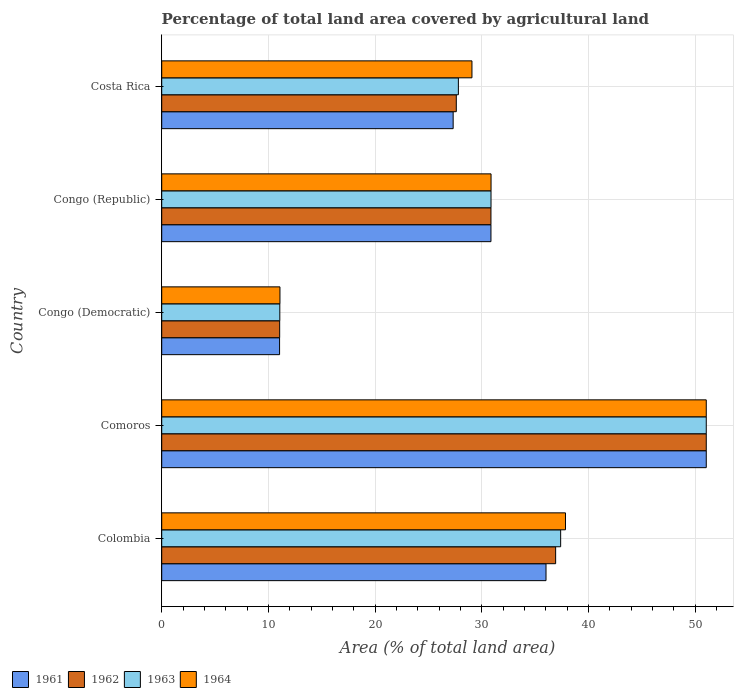How many different coloured bars are there?
Provide a short and direct response. 4. How many groups of bars are there?
Ensure brevity in your answer.  5. Are the number of bars on each tick of the Y-axis equal?
Make the answer very short. Yes. What is the label of the 4th group of bars from the top?
Your answer should be very brief. Comoros. In how many cases, is the number of bars for a given country not equal to the number of legend labels?
Offer a terse response. 0. What is the percentage of agricultural land in 1963 in Costa Rica?
Provide a succinct answer. 27.81. Across all countries, what is the maximum percentage of agricultural land in 1963?
Provide a succinct answer. 51.05. Across all countries, what is the minimum percentage of agricultural land in 1963?
Provide a short and direct response. 11.07. In which country was the percentage of agricultural land in 1963 maximum?
Offer a very short reply. Comoros. In which country was the percentage of agricultural land in 1962 minimum?
Make the answer very short. Congo (Democratic). What is the total percentage of agricultural land in 1961 in the graph?
Offer a very short reply. 156.31. What is the difference between the percentage of agricultural land in 1962 in Colombia and that in Comoros?
Offer a terse response. -14.12. What is the difference between the percentage of agricultural land in 1963 in Comoros and the percentage of agricultural land in 1964 in Congo (Republic)?
Offer a very short reply. 20.18. What is the average percentage of agricultural land in 1964 per country?
Your answer should be very brief. 31.99. What is the difference between the percentage of agricultural land in 1963 and percentage of agricultural land in 1961 in Comoros?
Offer a very short reply. 0. In how many countries, is the percentage of agricultural land in 1961 greater than 22 %?
Offer a terse response. 4. What is the ratio of the percentage of agricultural land in 1961 in Colombia to that in Comoros?
Offer a very short reply. 0.71. Is the percentage of agricultural land in 1964 in Congo (Republic) less than that in Costa Rica?
Your answer should be compact. No. Is the difference between the percentage of agricultural land in 1963 in Congo (Democratic) and Congo (Republic) greater than the difference between the percentage of agricultural land in 1961 in Congo (Democratic) and Congo (Republic)?
Your response must be concise. Yes. What is the difference between the highest and the second highest percentage of agricultural land in 1961?
Your answer should be very brief. 15.02. What is the difference between the highest and the lowest percentage of agricultural land in 1963?
Give a very brief answer. 39.98. Is the sum of the percentage of agricultural land in 1961 in Colombia and Costa Rica greater than the maximum percentage of agricultural land in 1962 across all countries?
Your answer should be compact. Yes. Is it the case that in every country, the sum of the percentage of agricultural land in 1964 and percentage of agricultural land in 1961 is greater than the sum of percentage of agricultural land in 1962 and percentage of agricultural land in 1963?
Your answer should be compact. No. Is it the case that in every country, the sum of the percentage of agricultural land in 1963 and percentage of agricultural land in 1962 is greater than the percentage of agricultural land in 1964?
Your answer should be compact. Yes. How many bars are there?
Your answer should be very brief. 20. What is the difference between two consecutive major ticks on the X-axis?
Your response must be concise. 10. Does the graph contain any zero values?
Make the answer very short. No. Does the graph contain grids?
Make the answer very short. Yes. How many legend labels are there?
Give a very brief answer. 4. What is the title of the graph?
Ensure brevity in your answer.  Percentage of total land area covered by agricultural land. What is the label or title of the X-axis?
Give a very brief answer. Area (% of total land area). What is the Area (% of total land area) of 1961 in Colombia?
Your response must be concise. 36.03. What is the Area (% of total land area) in 1962 in Colombia?
Offer a very short reply. 36.93. What is the Area (% of total land area) of 1963 in Colombia?
Provide a succinct answer. 37.4. What is the Area (% of total land area) in 1964 in Colombia?
Provide a succinct answer. 37.85. What is the Area (% of total land area) in 1961 in Comoros?
Your response must be concise. 51.05. What is the Area (% of total land area) of 1962 in Comoros?
Your response must be concise. 51.05. What is the Area (% of total land area) in 1963 in Comoros?
Your answer should be compact. 51.05. What is the Area (% of total land area) in 1964 in Comoros?
Your answer should be very brief. 51.05. What is the Area (% of total land area) of 1961 in Congo (Democratic)?
Give a very brief answer. 11.05. What is the Area (% of total land area) of 1962 in Congo (Democratic)?
Your answer should be compact. 11.06. What is the Area (% of total land area) in 1963 in Congo (Democratic)?
Your answer should be very brief. 11.07. What is the Area (% of total land area) of 1964 in Congo (Democratic)?
Your response must be concise. 11.08. What is the Area (% of total land area) of 1961 in Congo (Republic)?
Provide a succinct answer. 30.86. What is the Area (% of total land area) of 1962 in Congo (Republic)?
Provide a short and direct response. 30.86. What is the Area (% of total land area) of 1963 in Congo (Republic)?
Your response must be concise. 30.87. What is the Area (% of total land area) of 1964 in Congo (Republic)?
Offer a very short reply. 30.87. What is the Area (% of total land area) of 1961 in Costa Rica?
Keep it short and to the point. 27.32. What is the Area (% of total land area) in 1962 in Costa Rica?
Provide a short and direct response. 27.61. What is the Area (% of total land area) in 1963 in Costa Rica?
Give a very brief answer. 27.81. What is the Area (% of total land area) of 1964 in Costa Rica?
Your answer should be compact. 29.08. Across all countries, what is the maximum Area (% of total land area) of 1961?
Your answer should be compact. 51.05. Across all countries, what is the maximum Area (% of total land area) in 1962?
Your answer should be compact. 51.05. Across all countries, what is the maximum Area (% of total land area) of 1963?
Give a very brief answer. 51.05. Across all countries, what is the maximum Area (% of total land area) of 1964?
Make the answer very short. 51.05. Across all countries, what is the minimum Area (% of total land area) in 1961?
Your response must be concise. 11.05. Across all countries, what is the minimum Area (% of total land area) of 1962?
Offer a terse response. 11.06. Across all countries, what is the minimum Area (% of total land area) in 1963?
Keep it short and to the point. 11.07. Across all countries, what is the minimum Area (% of total land area) of 1964?
Your answer should be compact. 11.08. What is the total Area (% of total land area) in 1961 in the graph?
Provide a succinct answer. 156.31. What is the total Area (% of total land area) of 1962 in the graph?
Your answer should be compact. 157.51. What is the total Area (% of total land area) of 1963 in the graph?
Offer a terse response. 158.2. What is the total Area (% of total land area) of 1964 in the graph?
Give a very brief answer. 159.94. What is the difference between the Area (% of total land area) of 1961 in Colombia and that in Comoros?
Provide a succinct answer. -15.02. What is the difference between the Area (% of total land area) in 1962 in Colombia and that in Comoros?
Provide a short and direct response. -14.12. What is the difference between the Area (% of total land area) in 1963 in Colombia and that in Comoros?
Your answer should be very brief. -13.65. What is the difference between the Area (% of total land area) in 1964 in Colombia and that in Comoros?
Provide a short and direct response. -13.2. What is the difference between the Area (% of total land area) in 1961 in Colombia and that in Congo (Democratic)?
Give a very brief answer. 24.98. What is the difference between the Area (% of total land area) of 1962 in Colombia and that in Congo (Democratic)?
Offer a very short reply. 25.87. What is the difference between the Area (% of total land area) in 1963 in Colombia and that in Congo (Democratic)?
Keep it short and to the point. 26.33. What is the difference between the Area (% of total land area) of 1964 in Colombia and that in Congo (Democratic)?
Keep it short and to the point. 26.77. What is the difference between the Area (% of total land area) of 1961 in Colombia and that in Congo (Republic)?
Offer a very short reply. 5.16. What is the difference between the Area (% of total land area) of 1962 in Colombia and that in Congo (Republic)?
Give a very brief answer. 6.06. What is the difference between the Area (% of total land area) of 1963 in Colombia and that in Congo (Republic)?
Your response must be concise. 6.53. What is the difference between the Area (% of total land area) in 1964 in Colombia and that in Congo (Republic)?
Ensure brevity in your answer.  6.98. What is the difference between the Area (% of total land area) in 1961 in Colombia and that in Costa Rica?
Make the answer very short. 8.7. What is the difference between the Area (% of total land area) in 1962 in Colombia and that in Costa Rica?
Your answer should be very brief. 9.31. What is the difference between the Area (% of total land area) in 1963 in Colombia and that in Costa Rica?
Give a very brief answer. 9.59. What is the difference between the Area (% of total land area) of 1964 in Colombia and that in Costa Rica?
Ensure brevity in your answer.  8.77. What is the difference between the Area (% of total land area) of 1961 in Comoros and that in Congo (Democratic)?
Keep it short and to the point. 40. What is the difference between the Area (% of total land area) in 1962 in Comoros and that in Congo (Democratic)?
Give a very brief answer. 39.99. What is the difference between the Area (% of total land area) in 1963 in Comoros and that in Congo (Democratic)?
Ensure brevity in your answer.  39.98. What is the difference between the Area (% of total land area) of 1964 in Comoros and that in Congo (Democratic)?
Keep it short and to the point. 39.96. What is the difference between the Area (% of total land area) in 1961 in Comoros and that in Congo (Republic)?
Ensure brevity in your answer.  20.18. What is the difference between the Area (% of total land area) in 1962 in Comoros and that in Congo (Republic)?
Offer a very short reply. 20.18. What is the difference between the Area (% of total land area) in 1963 in Comoros and that in Congo (Republic)?
Offer a very short reply. 20.18. What is the difference between the Area (% of total land area) in 1964 in Comoros and that in Congo (Republic)?
Offer a terse response. 20.18. What is the difference between the Area (% of total land area) of 1961 in Comoros and that in Costa Rica?
Your answer should be very brief. 23.73. What is the difference between the Area (% of total land area) in 1962 in Comoros and that in Costa Rica?
Ensure brevity in your answer.  23.43. What is the difference between the Area (% of total land area) of 1963 in Comoros and that in Costa Rica?
Offer a very short reply. 23.24. What is the difference between the Area (% of total land area) in 1964 in Comoros and that in Costa Rica?
Ensure brevity in your answer.  21.96. What is the difference between the Area (% of total land area) in 1961 in Congo (Democratic) and that in Congo (Republic)?
Give a very brief answer. -19.81. What is the difference between the Area (% of total land area) of 1962 in Congo (Democratic) and that in Congo (Republic)?
Provide a short and direct response. -19.81. What is the difference between the Area (% of total land area) of 1963 in Congo (Democratic) and that in Congo (Republic)?
Your response must be concise. -19.8. What is the difference between the Area (% of total land area) of 1964 in Congo (Democratic) and that in Congo (Republic)?
Your answer should be compact. -19.79. What is the difference between the Area (% of total land area) in 1961 in Congo (Democratic) and that in Costa Rica?
Give a very brief answer. -16.27. What is the difference between the Area (% of total land area) in 1962 in Congo (Democratic) and that in Costa Rica?
Provide a succinct answer. -16.56. What is the difference between the Area (% of total land area) of 1963 in Congo (Democratic) and that in Costa Rica?
Make the answer very short. -16.74. What is the difference between the Area (% of total land area) in 1964 in Congo (Democratic) and that in Costa Rica?
Keep it short and to the point. -18. What is the difference between the Area (% of total land area) in 1961 in Congo (Republic) and that in Costa Rica?
Give a very brief answer. 3.54. What is the difference between the Area (% of total land area) in 1962 in Congo (Republic) and that in Costa Rica?
Your answer should be very brief. 3.25. What is the difference between the Area (% of total land area) of 1963 in Congo (Republic) and that in Costa Rica?
Offer a very short reply. 3.06. What is the difference between the Area (% of total land area) of 1964 in Congo (Republic) and that in Costa Rica?
Keep it short and to the point. 1.79. What is the difference between the Area (% of total land area) of 1961 in Colombia and the Area (% of total land area) of 1962 in Comoros?
Offer a very short reply. -15.02. What is the difference between the Area (% of total land area) in 1961 in Colombia and the Area (% of total land area) in 1963 in Comoros?
Provide a succinct answer. -15.02. What is the difference between the Area (% of total land area) in 1961 in Colombia and the Area (% of total land area) in 1964 in Comoros?
Provide a short and direct response. -15.02. What is the difference between the Area (% of total land area) in 1962 in Colombia and the Area (% of total land area) in 1963 in Comoros?
Your response must be concise. -14.12. What is the difference between the Area (% of total land area) of 1962 in Colombia and the Area (% of total land area) of 1964 in Comoros?
Keep it short and to the point. -14.12. What is the difference between the Area (% of total land area) of 1963 in Colombia and the Area (% of total land area) of 1964 in Comoros?
Keep it short and to the point. -13.65. What is the difference between the Area (% of total land area) of 1961 in Colombia and the Area (% of total land area) of 1962 in Congo (Democratic)?
Offer a terse response. 24.97. What is the difference between the Area (% of total land area) of 1961 in Colombia and the Area (% of total land area) of 1963 in Congo (Democratic)?
Give a very brief answer. 24.95. What is the difference between the Area (% of total land area) in 1961 in Colombia and the Area (% of total land area) in 1964 in Congo (Democratic)?
Offer a very short reply. 24.94. What is the difference between the Area (% of total land area) in 1962 in Colombia and the Area (% of total land area) in 1963 in Congo (Democratic)?
Provide a succinct answer. 25.86. What is the difference between the Area (% of total land area) in 1962 in Colombia and the Area (% of total land area) in 1964 in Congo (Democratic)?
Your answer should be compact. 25.84. What is the difference between the Area (% of total land area) in 1963 in Colombia and the Area (% of total land area) in 1964 in Congo (Democratic)?
Ensure brevity in your answer.  26.31. What is the difference between the Area (% of total land area) of 1961 in Colombia and the Area (% of total land area) of 1962 in Congo (Republic)?
Your answer should be very brief. 5.16. What is the difference between the Area (% of total land area) of 1961 in Colombia and the Area (% of total land area) of 1963 in Congo (Republic)?
Provide a succinct answer. 5.16. What is the difference between the Area (% of total land area) in 1961 in Colombia and the Area (% of total land area) in 1964 in Congo (Republic)?
Your answer should be compact. 5.15. What is the difference between the Area (% of total land area) of 1962 in Colombia and the Area (% of total land area) of 1963 in Congo (Republic)?
Your answer should be compact. 6.06. What is the difference between the Area (% of total land area) of 1962 in Colombia and the Area (% of total land area) of 1964 in Congo (Republic)?
Offer a very short reply. 6.06. What is the difference between the Area (% of total land area) of 1963 in Colombia and the Area (% of total land area) of 1964 in Congo (Republic)?
Keep it short and to the point. 6.53. What is the difference between the Area (% of total land area) of 1961 in Colombia and the Area (% of total land area) of 1962 in Costa Rica?
Keep it short and to the point. 8.41. What is the difference between the Area (% of total land area) of 1961 in Colombia and the Area (% of total land area) of 1963 in Costa Rica?
Provide a short and direct response. 8.21. What is the difference between the Area (% of total land area) of 1961 in Colombia and the Area (% of total land area) of 1964 in Costa Rica?
Offer a terse response. 6.94. What is the difference between the Area (% of total land area) of 1962 in Colombia and the Area (% of total land area) of 1963 in Costa Rica?
Make the answer very short. 9.12. What is the difference between the Area (% of total land area) of 1962 in Colombia and the Area (% of total land area) of 1964 in Costa Rica?
Provide a succinct answer. 7.84. What is the difference between the Area (% of total land area) in 1963 in Colombia and the Area (% of total land area) in 1964 in Costa Rica?
Offer a very short reply. 8.31. What is the difference between the Area (% of total land area) of 1961 in Comoros and the Area (% of total land area) of 1962 in Congo (Democratic)?
Your answer should be compact. 39.99. What is the difference between the Area (% of total land area) of 1961 in Comoros and the Area (% of total land area) of 1963 in Congo (Democratic)?
Your answer should be very brief. 39.98. What is the difference between the Area (% of total land area) of 1961 in Comoros and the Area (% of total land area) of 1964 in Congo (Democratic)?
Your answer should be compact. 39.96. What is the difference between the Area (% of total land area) of 1962 in Comoros and the Area (% of total land area) of 1963 in Congo (Democratic)?
Offer a very short reply. 39.98. What is the difference between the Area (% of total land area) in 1962 in Comoros and the Area (% of total land area) in 1964 in Congo (Democratic)?
Provide a succinct answer. 39.96. What is the difference between the Area (% of total land area) in 1963 in Comoros and the Area (% of total land area) in 1964 in Congo (Democratic)?
Keep it short and to the point. 39.96. What is the difference between the Area (% of total land area) in 1961 in Comoros and the Area (% of total land area) in 1962 in Congo (Republic)?
Give a very brief answer. 20.18. What is the difference between the Area (% of total land area) in 1961 in Comoros and the Area (% of total land area) in 1963 in Congo (Republic)?
Keep it short and to the point. 20.18. What is the difference between the Area (% of total land area) of 1961 in Comoros and the Area (% of total land area) of 1964 in Congo (Republic)?
Keep it short and to the point. 20.18. What is the difference between the Area (% of total land area) in 1962 in Comoros and the Area (% of total land area) in 1963 in Congo (Republic)?
Offer a terse response. 20.18. What is the difference between the Area (% of total land area) of 1962 in Comoros and the Area (% of total land area) of 1964 in Congo (Republic)?
Make the answer very short. 20.18. What is the difference between the Area (% of total land area) in 1963 in Comoros and the Area (% of total land area) in 1964 in Congo (Republic)?
Keep it short and to the point. 20.18. What is the difference between the Area (% of total land area) of 1961 in Comoros and the Area (% of total land area) of 1962 in Costa Rica?
Make the answer very short. 23.43. What is the difference between the Area (% of total land area) in 1961 in Comoros and the Area (% of total land area) in 1963 in Costa Rica?
Provide a succinct answer. 23.24. What is the difference between the Area (% of total land area) of 1961 in Comoros and the Area (% of total land area) of 1964 in Costa Rica?
Your response must be concise. 21.96. What is the difference between the Area (% of total land area) in 1962 in Comoros and the Area (% of total land area) in 1963 in Costa Rica?
Your answer should be compact. 23.24. What is the difference between the Area (% of total land area) in 1962 in Comoros and the Area (% of total land area) in 1964 in Costa Rica?
Ensure brevity in your answer.  21.96. What is the difference between the Area (% of total land area) in 1963 in Comoros and the Area (% of total land area) in 1964 in Costa Rica?
Offer a very short reply. 21.96. What is the difference between the Area (% of total land area) in 1961 in Congo (Democratic) and the Area (% of total land area) in 1962 in Congo (Republic)?
Your answer should be very brief. -19.81. What is the difference between the Area (% of total land area) of 1961 in Congo (Democratic) and the Area (% of total land area) of 1963 in Congo (Republic)?
Offer a very short reply. -19.82. What is the difference between the Area (% of total land area) of 1961 in Congo (Democratic) and the Area (% of total land area) of 1964 in Congo (Republic)?
Provide a short and direct response. -19.82. What is the difference between the Area (% of total land area) in 1962 in Congo (Democratic) and the Area (% of total land area) in 1963 in Congo (Republic)?
Your answer should be very brief. -19.81. What is the difference between the Area (% of total land area) of 1962 in Congo (Democratic) and the Area (% of total land area) of 1964 in Congo (Republic)?
Provide a succinct answer. -19.81. What is the difference between the Area (% of total land area) of 1963 in Congo (Democratic) and the Area (% of total land area) of 1964 in Congo (Republic)?
Your answer should be compact. -19.8. What is the difference between the Area (% of total land area) in 1961 in Congo (Democratic) and the Area (% of total land area) in 1962 in Costa Rica?
Offer a very short reply. -16.57. What is the difference between the Area (% of total land area) in 1961 in Congo (Democratic) and the Area (% of total land area) in 1963 in Costa Rica?
Give a very brief answer. -16.76. What is the difference between the Area (% of total land area) in 1961 in Congo (Democratic) and the Area (% of total land area) in 1964 in Costa Rica?
Your answer should be very brief. -18.03. What is the difference between the Area (% of total land area) in 1962 in Congo (Democratic) and the Area (% of total land area) in 1963 in Costa Rica?
Keep it short and to the point. -16.75. What is the difference between the Area (% of total land area) of 1962 in Congo (Democratic) and the Area (% of total land area) of 1964 in Costa Rica?
Keep it short and to the point. -18.02. What is the difference between the Area (% of total land area) of 1963 in Congo (Democratic) and the Area (% of total land area) of 1964 in Costa Rica?
Ensure brevity in your answer.  -18.01. What is the difference between the Area (% of total land area) of 1961 in Congo (Republic) and the Area (% of total land area) of 1962 in Costa Rica?
Your answer should be very brief. 3.25. What is the difference between the Area (% of total land area) of 1961 in Congo (Republic) and the Area (% of total land area) of 1963 in Costa Rica?
Offer a very short reply. 3.05. What is the difference between the Area (% of total land area) in 1961 in Congo (Republic) and the Area (% of total land area) in 1964 in Costa Rica?
Provide a short and direct response. 1.78. What is the difference between the Area (% of total land area) in 1962 in Congo (Republic) and the Area (% of total land area) in 1963 in Costa Rica?
Your response must be concise. 3.05. What is the difference between the Area (% of total land area) of 1962 in Congo (Republic) and the Area (% of total land area) of 1964 in Costa Rica?
Your answer should be very brief. 1.78. What is the difference between the Area (% of total land area) of 1963 in Congo (Republic) and the Area (% of total land area) of 1964 in Costa Rica?
Ensure brevity in your answer.  1.79. What is the average Area (% of total land area) in 1961 per country?
Make the answer very short. 31.26. What is the average Area (% of total land area) of 1962 per country?
Provide a short and direct response. 31.5. What is the average Area (% of total land area) in 1963 per country?
Ensure brevity in your answer.  31.64. What is the average Area (% of total land area) of 1964 per country?
Your answer should be compact. 31.99. What is the difference between the Area (% of total land area) in 1961 and Area (% of total land area) in 1962 in Colombia?
Provide a short and direct response. -0.9. What is the difference between the Area (% of total land area) in 1961 and Area (% of total land area) in 1963 in Colombia?
Ensure brevity in your answer.  -1.37. What is the difference between the Area (% of total land area) in 1961 and Area (% of total land area) in 1964 in Colombia?
Offer a very short reply. -1.83. What is the difference between the Area (% of total land area) in 1962 and Area (% of total land area) in 1963 in Colombia?
Give a very brief answer. -0.47. What is the difference between the Area (% of total land area) of 1962 and Area (% of total land area) of 1964 in Colombia?
Provide a succinct answer. -0.92. What is the difference between the Area (% of total land area) of 1963 and Area (% of total land area) of 1964 in Colombia?
Provide a short and direct response. -0.45. What is the difference between the Area (% of total land area) of 1961 and Area (% of total land area) of 1962 in Comoros?
Offer a terse response. 0. What is the difference between the Area (% of total land area) in 1961 and Area (% of total land area) in 1963 in Comoros?
Your answer should be very brief. 0. What is the difference between the Area (% of total land area) in 1961 and Area (% of total land area) in 1964 in Comoros?
Give a very brief answer. 0. What is the difference between the Area (% of total land area) in 1962 and Area (% of total land area) in 1963 in Comoros?
Provide a succinct answer. 0. What is the difference between the Area (% of total land area) in 1962 and Area (% of total land area) in 1964 in Comoros?
Provide a short and direct response. 0. What is the difference between the Area (% of total land area) of 1961 and Area (% of total land area) of 1962 in Congo (Democratic)?
Provide a short and direct response. -0.01. What is the difference between the Area (% of total land area) in 1961 and Area (% of total land area) in 1963 in Congo (Democratic)?
Provide a short and direct response. -0.02. What is the difference between the Area (% of total land area) in 1961 and Area (% of total land area) in 1964 in Congo (Democratic)?
Your answer should be compact. -0.04. What is the difference between the Area (% of total land area) in 1962 and Area (% of total land area) in 1963 in Congo (Democratic)?
Provide a short and direct response. -0.01. What is the difference between the Area (% of total land area) of 1962 and Area (% of total land area) of 1964 in Congo (Democratic)?
Ensure brevity in your answer.  -0.03. What is the difference between the Area (% of total land area) of 1963 and Area (% of total land area) of 1964 in Congo (Democratic)?
Your answer should be compact. -0.01. What is the difference between the Area (% of total land area) in 1961 and Area (% of total land area) in 1962 in Congo (Republic)?
Your response must be concise. 0. What is the difference between the Area (% of total land area) of 1961 and Area (% of total land area) of 1963 in Congo (Republic)?
Make the answer very short. -0.01. What is the difference between the Area (% of total land area) in 1961 and Area (% of total land area) in 1964 in Congo (Republic)?
Give a very brief answer. -0.01. What is the difference between the Area (% of total land area) in 1962 and Area (% of total land area) in 1963 in Congo (Republic)?
Keep it short and to the point. -0.01. What is the difference between the Area (% of total land area) of 1962 and Area (% of total land area) of 1964 in Congo (Republic)?
Provide a succinct answer. -0.01. What is the difference between the Area (% of total land area) in 1963 and Area (% of total land area) in 1964 in Congo (Republic)?
Provide a succinct answer. -0. What is the difference between the Area (% of total land area) of 1961 and Area (% of total land area) of 1962 in Costa Rica?
Your answer should be very brief. -0.29. What is the difference between the Area (% of total land area) of 1961 and Area (% of total land area) of 1963 in Costa Rica?
Make the answer very short. -0.49. What is the difference between the Area (% of total land area) of 1961 and Area (% of total land area) of 1964 in Costa Rica?
Provide a succinct answer. -1.76. What is the difference between the Area (% of total land area) in 1962 and Area (% of total land area) in 1963 in Costa Rica?
Offer a terse response. -0.2. What is the difference between the Area (% of total land area) of 1962 and Area (% of total land area) of 1964 in Costa Rica?
Give a very brief answer. -1.47. What is the difference between the Area (% of total land area) of 1963 and Area (% of total land area) of 1964 in Costa Rica?
Give a very brief answer. -1.27. What is the ratio of the Area (% of total land area) of 1961 in Colombia to that in Comoros?
Ensure brevity in your answer.  0.71. What is the ratio of the Area (% of total land area) of 1962 in Colombia to that in Comoros?
Provide a succinct answer. 0.72. What is the ratio of the Area (% of total land area) of 1963 in Colombia to that in Comoros?
Provide a succinct answer. 0.73. What is the ratio of the Area (% of total land area) in 1964 in Colombia to that in Comoros?
Ensure brevity in your answer.  0.74. What is the ratio of the Area (% of total land area) in 1961 in Colombia to that in Congo (Democratic)?
Your answer should be very brief. 3.26. What is the ratio of the Area (% of total land area) in 1962 in Colombia to that in Congo (Democratic)?
Ensure brevity in your answer.  3.34. What is the ratio of the Area (% of total land area) of 1963 in Colombia to that in Congo (Democratic)?
Make the answer very short. 3.38. What is the ratio of the Area (% of total land area) in 1964 in Colombia to that in Congo (Democratic)?
Your response must be concise. 3.41. What is the ratio of the Area (% of total land area) of 1961 in Colombia to that in Congo (Republic)?
Give a very brief answer. 1.17. What is the ratio of the Area (% of total land area) of 1962 in Colombia to that in Congo (Republic)?
Provide a short and direct response. 1.2. What is the ratio of the Area (% of total land area) of 1963 in Colombia to that in Congo (Republic)?
Your response must be concise. 1.21. What is the ratio of the Area (% of total land area) in 1964 in Colombia to that in Congo (Republic)?
Your response must be concise. 1.23. What is the ratio of the Area (% of total land area) of 1961 in Colombia to that in Costa Rica?
Your answer should be compact. 1.32. What is the ratio of the Area (% of total land area) of 1962 in Colombia to that in Costa Rica?
Give a very brief answer. 1.34. What is the ratio of the Area (% of total land area) of 1963 in Colombia to that in Costa Rica?
Your response must be concise. 1.34. What is the ratio of the Area (% of total land area) of 1964 in Colombia to that in Costa Rica?
Give a very brief answer. 1.3. What is the ratio of the Area (% of total land area) in 1961 in Comoros to that in Congo (Democratic)?
Offer a terse response. 4.62. What is the ratio of the Area (% of total land area) of 1962 in Comoros to that in Congo (Democratic)?
Offer a very short reply. 4.62. What is the ratio of the Area (% of total land area) in 1963 in Comoros to that in Congo (Democratic)?
Offer a terse response. 4.61. What is the ratio of the Area (% of total land area) in 1964 in Comoros to that in Congo (Democratic)?
Your answer should be very brief. 4.61. What is the ratio of the Area (% of total land area) in 1961 in Comoros to that in Congo (Republic)?
Offer a terse response. 1.65. What is the ratio of the Area (% of total land area) in 1962 in Comoros to that in Congo (Republic)?
Provide a succinct answer. 1.65. What is the ratio of the Area (% of total land area) of 1963 in Comoros to that in Congo (Republic)?
Ensure brevity in your answer.  1.65. What is the ratio of the Area (% of total land area) of 1964 in Comoros to that in Congo (Republic)?
Offer a very short reply. 1.65. What is the ratio of the Area (% of total land area) of 1961 in Comoros to that in Costa Rica?
Ensure brevity in your answer.  1.87. What is the ratio of the Area (% of total land area) of 1962 in Comoros to that in Costa Rica?
Keep it short and to the point. 1.85. What is the ratio of the Area (% of total land area) of 1963 in Comoros to that in Costa Rica?
Your answer should be very brief. 1.84. What is the ratio of the Area (% of total land area) in 1964 in Comoros to that in Costa Rica?
Your response must be concise. 1.76. What is the ratio of the Area (% of total land area) in 1961 in Congo (Democratic) to that in Congo (Republic)?
Keep it short and to the point. 0.36. What is the ratio of the Area (% of total land area) in 1962 in Congo (Democratic) to that in Congo (Republic)?
Offer a terse response. 0.36. What is the ratio of the Area (% of total land area) of 1963 in Congo (Democratic) to that in Congo (Republic)?
Offer a very short reply. 0.36. What is the ratio of the Area (% of total land area) of 1964 in Congo (Democratic) to that in Congo (Republic)?
Ensure brevity in your answer.  0.36. What is the ratio of the Area (% of total land area) in 1961 in Congo (Democratic) to that in Costa Rica?
Keep it short and to the point. 0.4. What is the ratio of the Area (% of total land area) in 1962 in Congo (Democratic) to that in Costa Rica?
Give a very brief answer. 0.4. What is the ratio of the Area (% of total land area) in 1963 in Congo (Democratic) to that in Costa Rica?
Your answer should be compact. 0.4. What is the ratio of the Area (% of total land area) in 1964 in Congo (Democratic) to that in Costa Rica?
Your response must be concise. 0.38. What is the ratio of the Area (% of total land area) in 1961 in Congo (Republic) to that in Costa Rica?
Provide a succinct answer. 1.13. What is the ratio of the Area (% of total land area) in 1962 in Congo (Republic) to that in Costa Rica?
Provide a short and direct response. 1.12. What is the ratio of the Area (% of total land area) of 1963 in Congo (Republic) to that in Costa Rica?
Offer a terse response. 1.11. What is the ratio of the Area (% of total land area) of 1964 in Congo (Republic) to that in Costa Rica?
Your response must be concise. 1.06. What is the difference between the highest and the second highest Area (% of total land area) in 1961?
Provide a succinct answer. 15.02. What is the difference between the highest and the second highest Area (% of total land area) of 1962?
Offer a very short reply. 14.12. What is the difference between the highest and the second highest Area (% of total land area) of 1963?
Keep it short and to the point. 13.65. What is the difference between the highest and the second highest Area (% of total land area) in 1964?
Give a very brief answer. 13.2. What is the difference between the highest and the lowest Area (% of total land area) of 1961?
Ensure brevity in your answer.  40. What is the difference between the highest and the lowest Area (% of total land area) in 1962?
Provide a short and direct response. 39.99. What is the difference between the highest and the lowest Area (% of total land area) in 1963?
Ensure brevity in your answer.  39.98. What is the difference between the highest and the lowest Area (% of total land area) in 1964?
Your response must be concise. 39.96. 